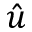<formula> <loc_0><loc_0><loc_500><loc_500>\hat { u }</formula> 